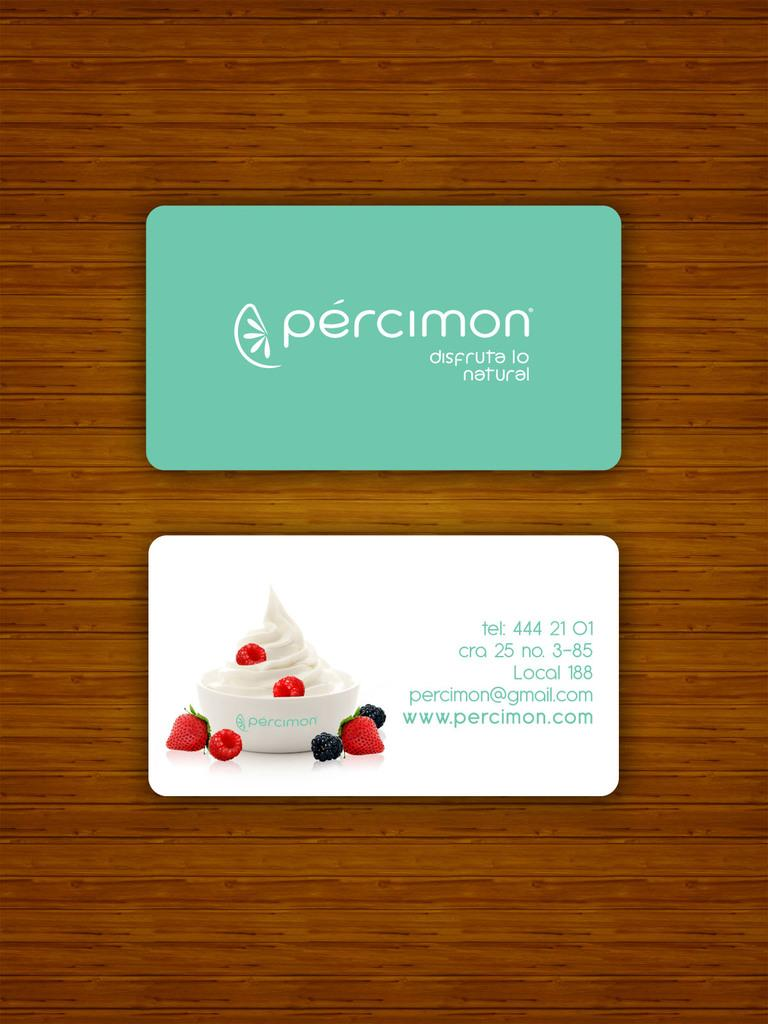What is the main object in the image with text and a logo? There is a card with text and a logo in the image. What is the appearance of the second card in the image? The second card is white and has text, numbers, and fruits on it. What is in the white bowl in the image? There is food in the white bowl in the image. What can be seen behind the objects in the image? The background of the image appears to be a wall. How does the card with text and a logo provide pleasure in the image? The card with text and a logo does not provide pleasure in the image; it is simply an object with text and a logo. What type of tongue is depicted on the white card with text, numbers, and fruits? There is no tongue depicted on the white card with text, numbers, and fruits; it only contains text, numbers, and images of fruits. 